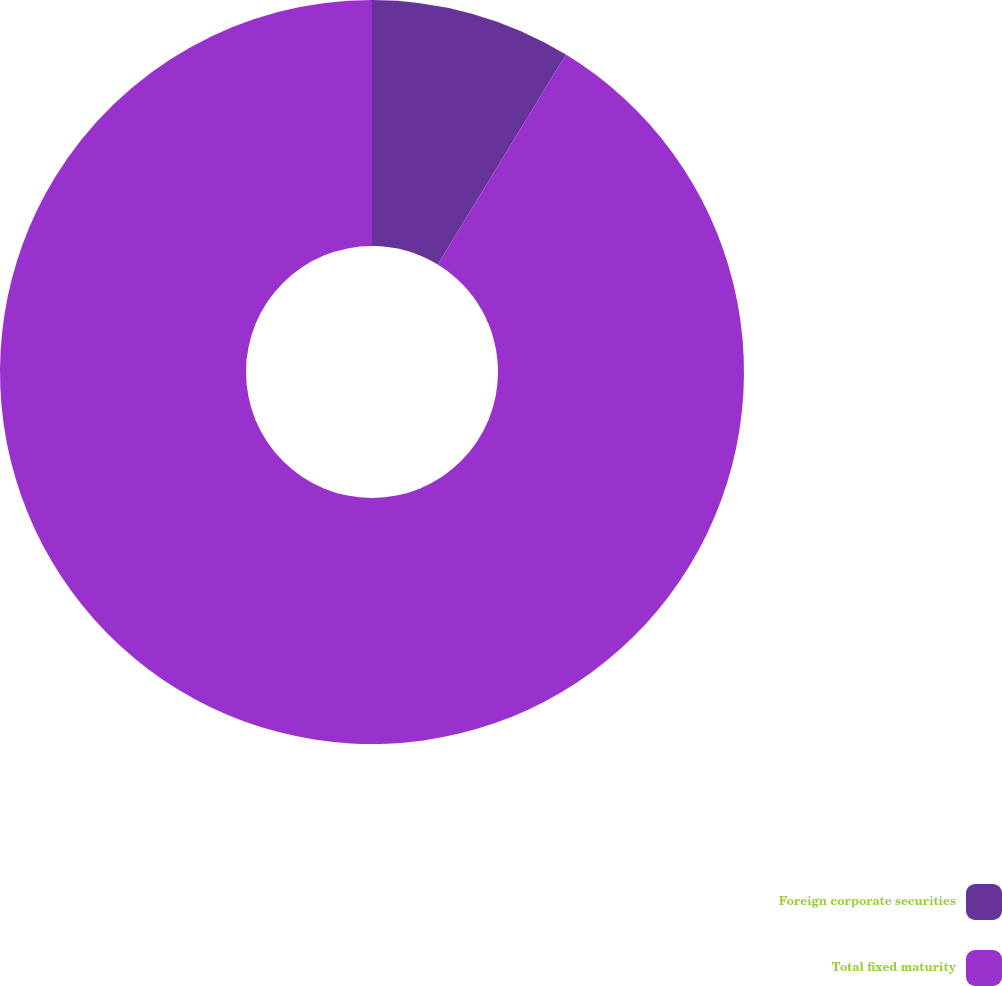Convert chart to OTSL. <chart><loc_0><loc_0><loc_500><loc_500><pie_chart><fcel>Foreign corporate securities<fcel>Total fixed maturity<nl><fcel>8.73%<fcel>91.27%<nl></chart> 